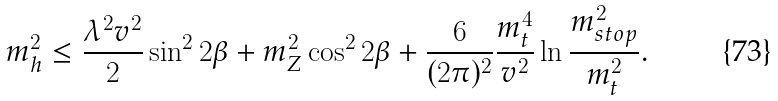<formula> <loc_0><loc_0><loc_500><loc_500>m _ { h } ^ { 2 } \leq \frac { \lambda ^ { 2 } v ^ { 2 } } { 2 } \sin ^ { 2 } { 2 \beta } + m _ { Z } ^ { 2 } \cos ^ { 2 } { 2 \beta } + \frac { 6 } { ( 2 \pi ) ^ { 2 } } \frac { m _ { t } ^ { 4 } } { v ^ { 2 } } \ln { \frac { m _ { s t o p } ^ { 2 } } { m _ { t } ^ { 2 } } } .</formula> 